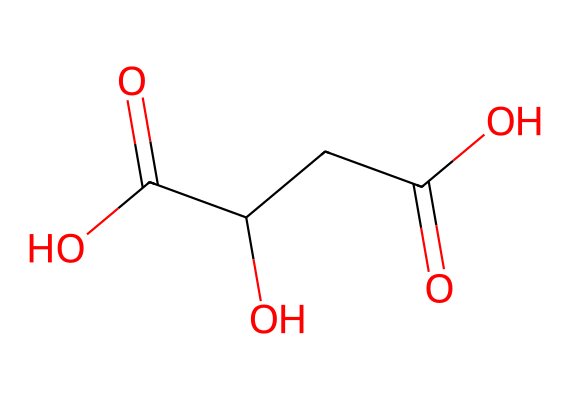How many carbon atoms are in the chemical structure? By examining the SMILES representation, we can count the number of carbon (C) atoms, which are represented directly in the string. There are four carbon atoms present in the structure.
Answer: four What is the main functional group present in this chemical? The SMILES indicates the presence of carboxylic acid groups, which can be identified by the presence of the -C(=O)O structure in the representation. There are two such groups in this molecule.
Answer: carboxylic acid What is the degree of saturation of the compound? We observe that the chemical structure contains multiple bonds (double bonds in the carbonyl groups) and no rings, indicating a degree of saturation that correlates to its structure. Given the number of carbon and oxygen atoms, we find the degree of saturation to be low as it can form hydrogen bonds.
Answer: low Is this compound considered a biodegradable plastic? The presence of carboxylic acid groups and the overall structure suggest that this compound can undergo hydrolysis, meaning it is likely to degrade in natural environments, thus classifying it as biodegradable.
Answer: biodegradable What is the total number of oxygen atoms in the structure? Counting the instances of the oxygen (O) atoms present in the SMILES representation, we find that there are three oxygen atoms in total.
Answer: three What type of monomer might this structure be based on? This chemical represents a structure related to natural biopolymers, especially those derived from renewable sources, pointing toward polylactic acid or similar biodegradable sources.
Answer: lactate Which feature of this chemical suggests its eco-friendliness? The presence of functional groups such as carboxylic acids indicates that this compound can readily break down in nature, making it a more environmentally friendly choice for packaging.
Answer: carboxylic acids 